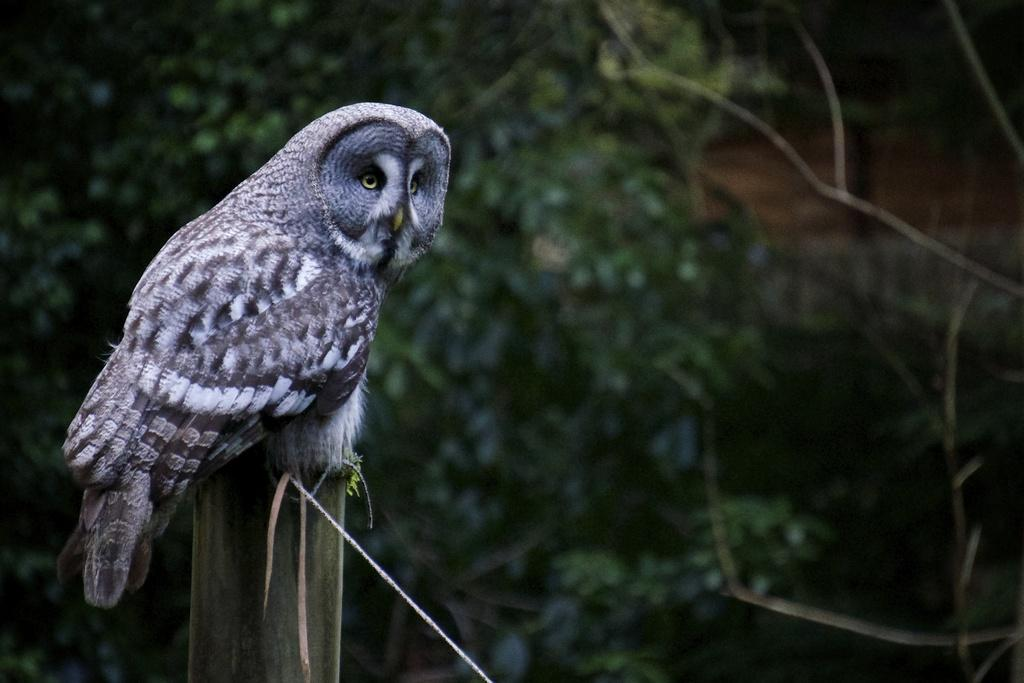What animal can be seen in the picture? There is an owl in the picture. Where is the owl located? The owl is on a wooden pole. What can be seen in the background of the image? There are trees in the background of the image. What type of pollution is visible in the image? There is no pollution visible in the image; it features an owl on a wooden pole with trees in the background. How many cats can be seen interacting with the owl in the image? There are no cats present in the image. 